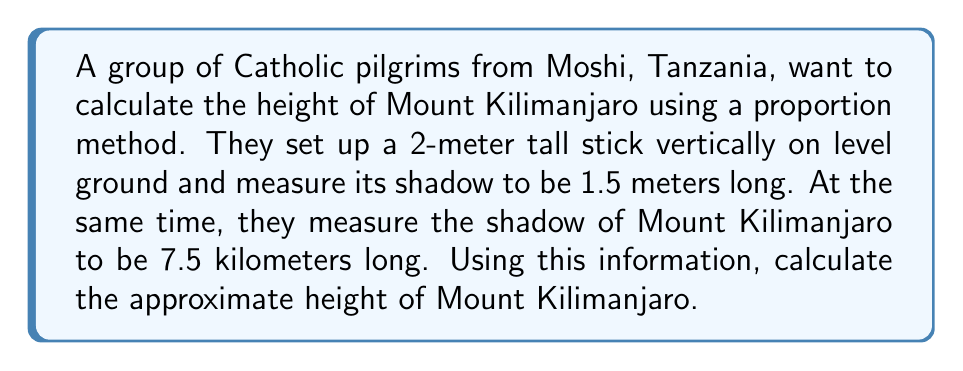Provide a solution to this math problem. Let's solve this step-by-step using a proportion:

1) We know that similar triangles have proportional sides. The triangle formed by the stick and its shadow is similar to the triangle formed by the mountain and its shadow.

2) Let's set up our proportion:
   $\frac{\text{Stick Height}}{\text{Stick Shadow}} = \frac{\text{Mountain Height}}{\text{Mountain Shadow}}$

3) Let $x$ be the height of Mount Kilimanjaro. We can now fill in our known values:
   $\frac{2 \text{ m}}{1.5 \text{ m}} = \frac{x}{7.5 \text{ km}}$

4) To solve for $x$, we first cross-multiply:
   $2 \cdot 7.5 = 1.5x$

5) Simplify:
   $15 = 1.5x$

6) Divide both sides by 1.5:
   $\frac{15}{1.5} = x$

7) Simplify:
   $10 = x$

8) However, we need to be careful with our units. The mountain's shadow was measured in kilometers, so our answer should be in kilometers as well.

Therefore, Mount Kilimanjaro is approximately 10 kilometers tall.
Answer: 10 km 